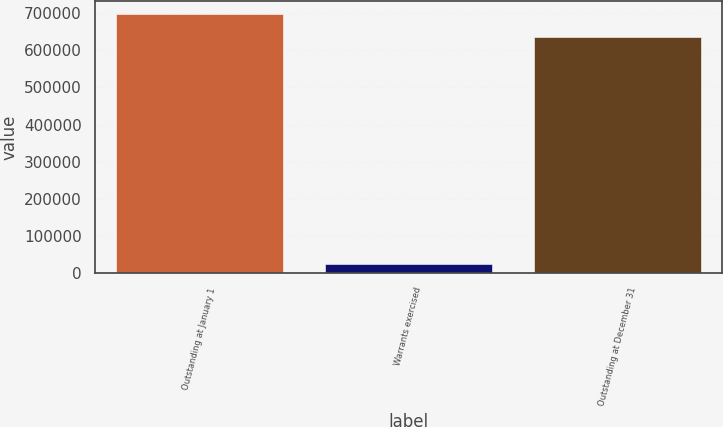<chart> <loc_0><loc_0><loc_500><loc_500><bar_chart><fcel>Outstanding at January 1<fcel>Warrants exercised<fcel>Outstanding at December 31<nl><fcel>698072<fcel>25105<fcel>634611<nl></chart> 